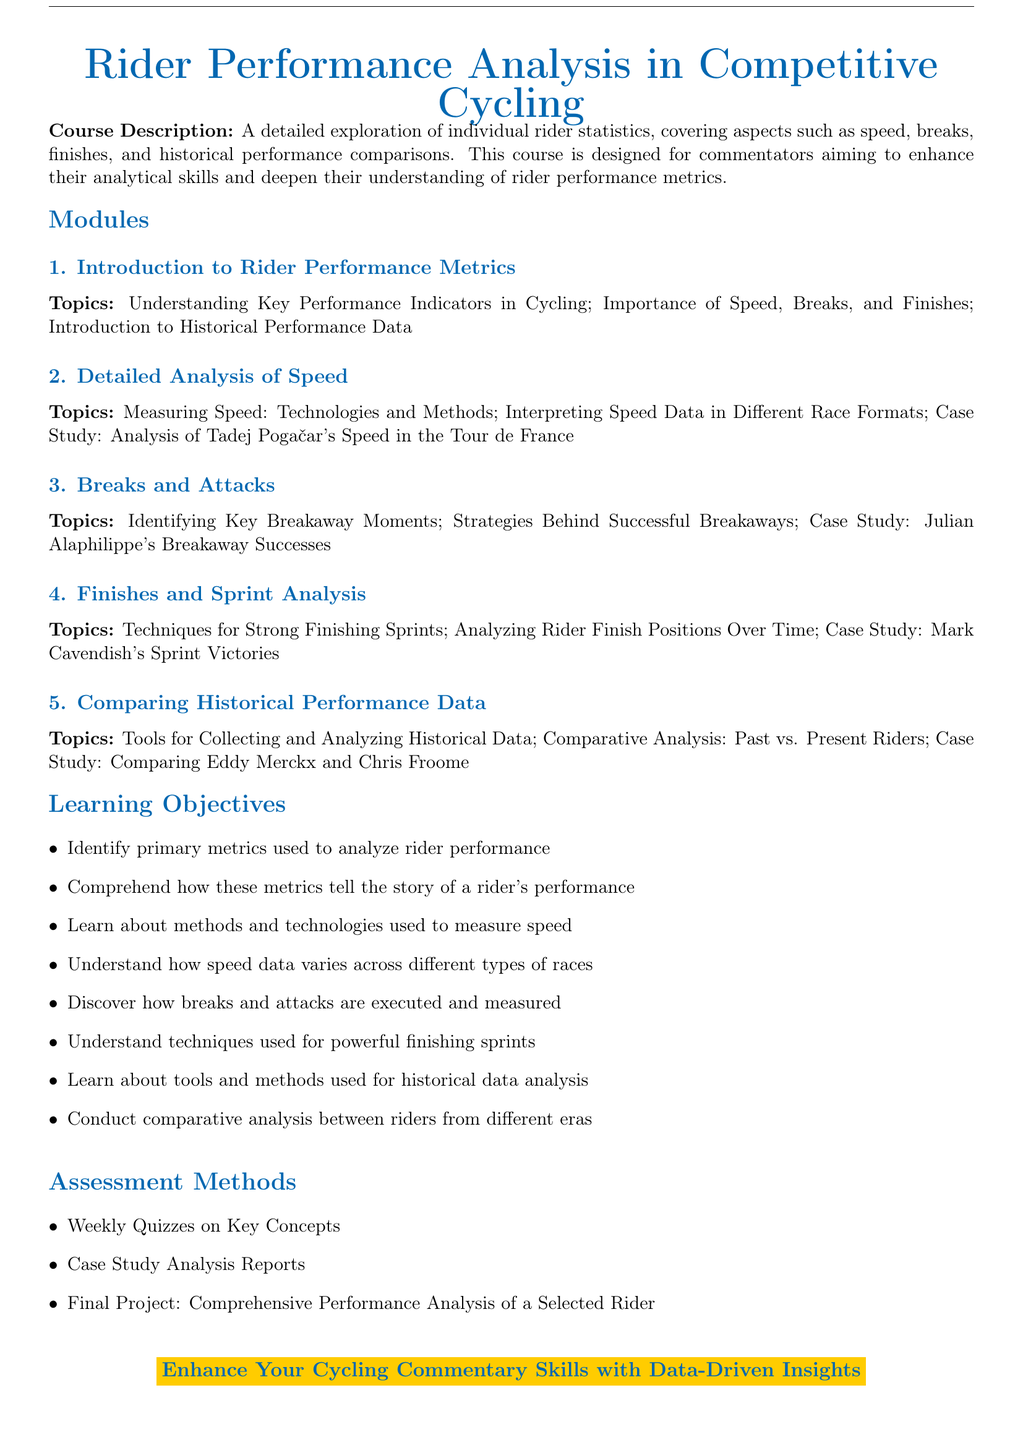What is the title of the document? The title is clearly stated at the beginning of the document and is "Rider Performance Analysis in Competitive Cycling."
Answer: Rider Performance Analysis in Competitive Cycling What is the focus of this course? The course description outlines that it focuses on individual rider statistics, covering aspects such as speed, breaks, and finishes.
Answer: Individual rider statistics Who is the case study subject for speed analysis? The document lists Tadej Pogačar as the subject of the case study for speed analysis in the Tour de France.
Answer: Tadej Pogačar What are the assessment methods mentioned in the syllabus? The syllabus includes various methods such as quizzes, case study analysis reports, and a final project.
Answer: Weekly quizzes, case study analysis reports, final project What is one learning objective related to breakaway strategies? One of the learning objectives is to discover how breaks and attacks are executed and measured.
Answer: Breaks and attacks execution Which section covers sprint analysis? The section dedicated to sprint analysis is titled "Finishes and Sprint Analysis."
Answer: Finishes and Sprint Analysis How many modules are there in the syllabus? The document lists a total of five modules regarding rider performance analysis.
Answer: Five modules What color is used for the headings in the document? The color defined for the headings is referred to as cycling blue.
Answer: Cycling blue 